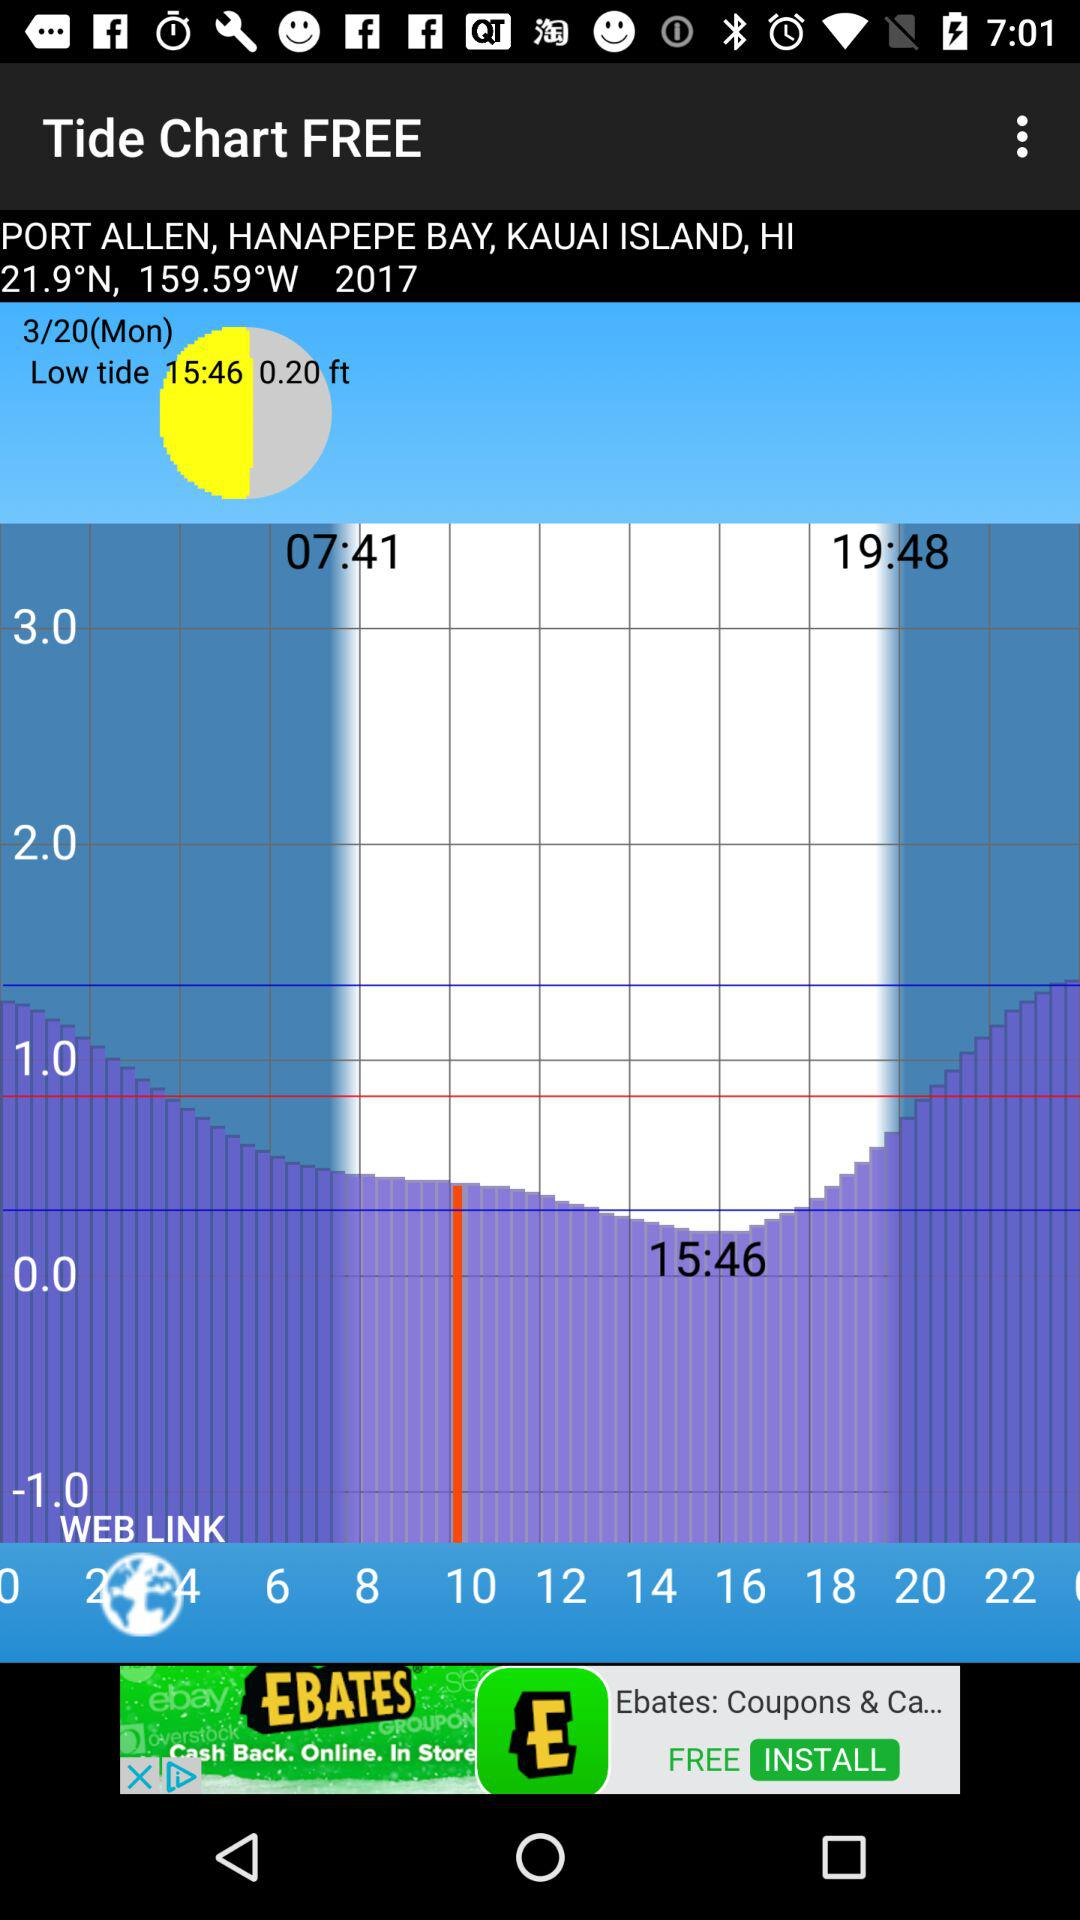What is the name of the port? The name of the port is Allen. 